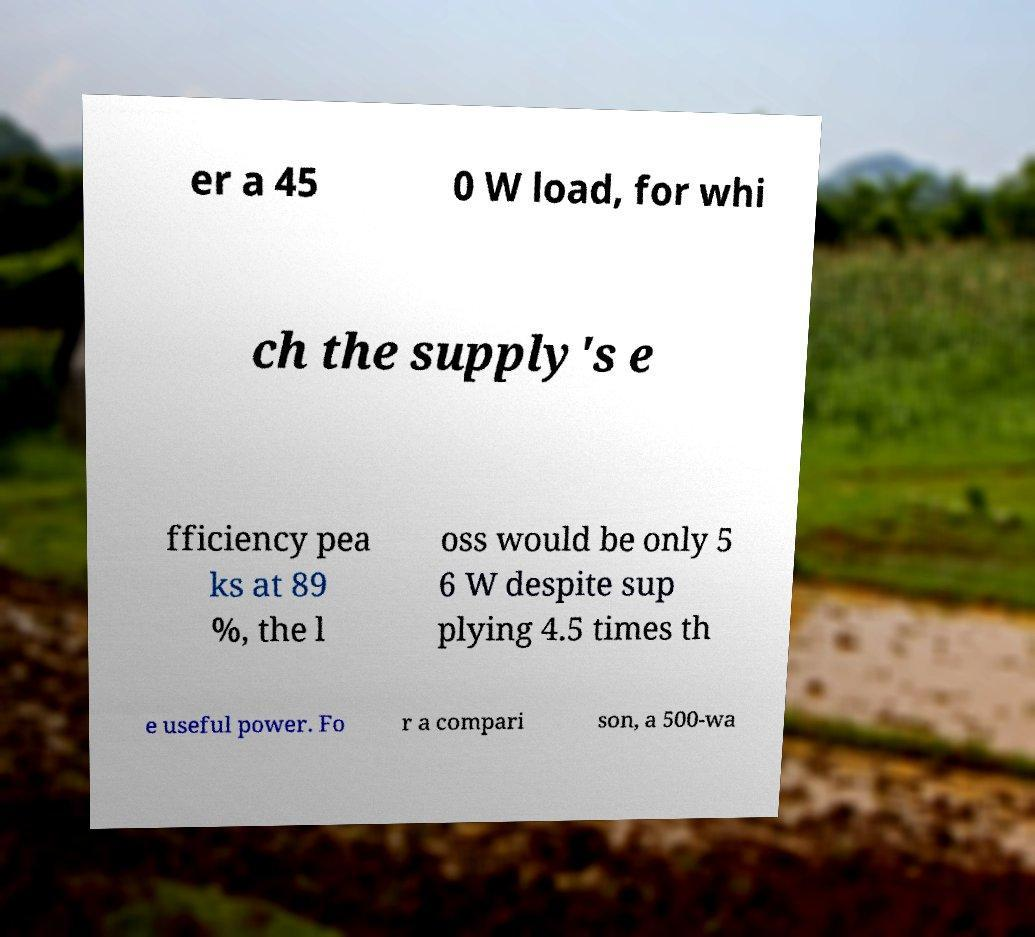Could you extract and type out the text from this image? er a 45 0 W load, for whi ch the supply's e fficiency pea ks at 89 %, the l oss would be only 5 6 W despite sup plying 4.5 times th e useful power. Fo r a compari son, a 500-wa 